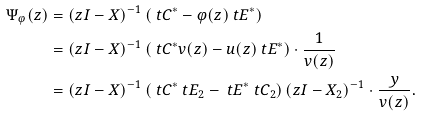<formula> <loc_0><loc_0><loc_500><loc_500>\Psi _ { \varphi } ( z ) & = ( z I - X ) ^ { - 1 } \left ( \ t C ^ { * } - \varphi ( z ) \ t E ^ { * } \right ) \\ & = ( z I - X ) ^ { - 1 } \left ( \ t C ^ { * } v ( z ) - u ( z ) \ t E ^ { * } \right ) \cdot \frac { 1 } { v ( z ) } \\ & = ( z I - X ) ^ { - 1 } \left ( \ t C ^ { * } \ t E _ { 2 } - \ t E ^ { * } \ t C _ { 2 } \right ) ( z I - X _ { 2 } ) ^ { - 1 } \cdot \frac { y } { v ( z ) } .</formula> 